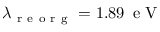Convert formula to latex. <formula><loc_0><loc_0><loc_500><loc_500>\lambda _ { r e o r g } = 1 . 8 9 \, e V</formula> 